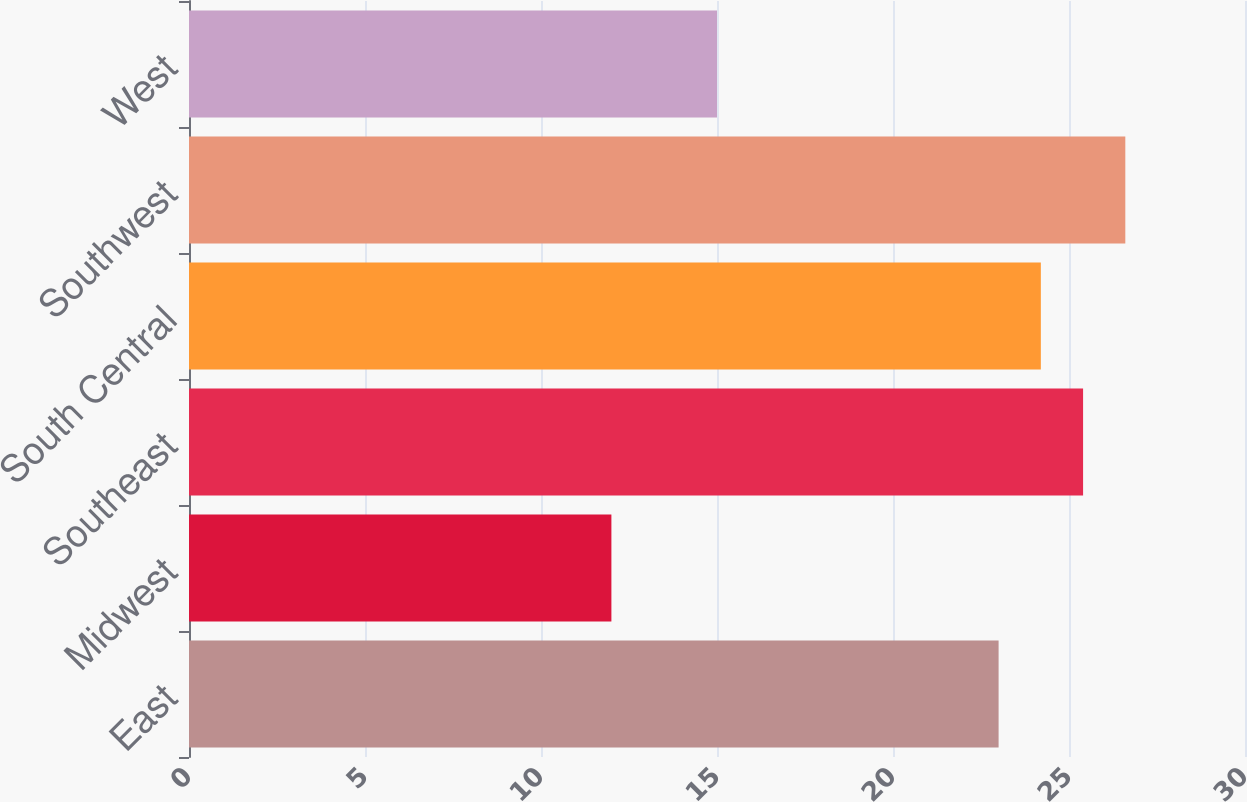<chart> <loc_0><loc_0><loc_500><loc_500><bar_chart><fcel>East<fcel>Midwest<fcel>Southeast<fcel>South Central<fcel>Southwest<fcel>West<nl><fcel>23<fcel>12<fcel>25.4<fcel>24.2<fcel>26.6<fcel>15<nl></chart> 